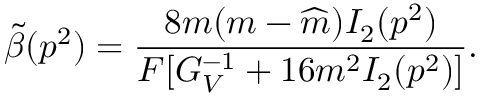<formula> <loc_0><loc_0><loc_500><loc_500>\tilde { \beta } ( p ^ { 2 } ) = \frac { 8 m ( m - \widehat { m } ) I _ { 2 } ( p ^ { 2 } ) } { F [ G _ { V } ^ { - 1 } + 1 6 m ^ { 2 } I _ { 2 } ( p ^ { 2 } ) ] } .</formula> 